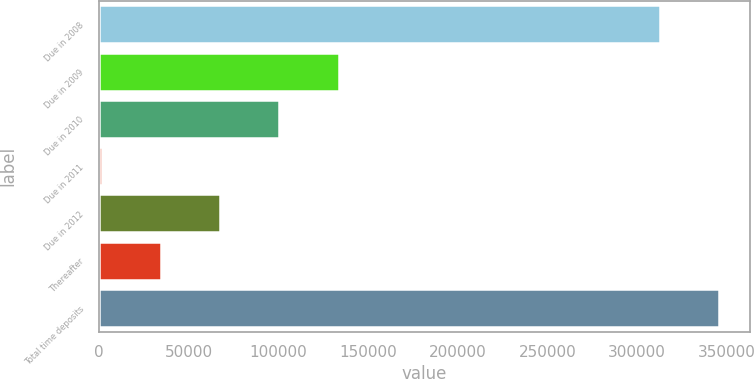Convert chart to OTSL. <chart><loc_0><loc_0><loc_500><loc_500><bar_chart><fcel>Due in 2008<fcel>Due in 2009<fcel>Due in 2010<fcel>Due in 2011<fcel>Due in 2012<fcel>Thereafter<fcel>Total time deposits<nl><fcel>312693<fcel>133708<fcel>100679<fcel>1592<fcel>67650.2<fcel>34621.1<fcel>345722<nl></chart> 